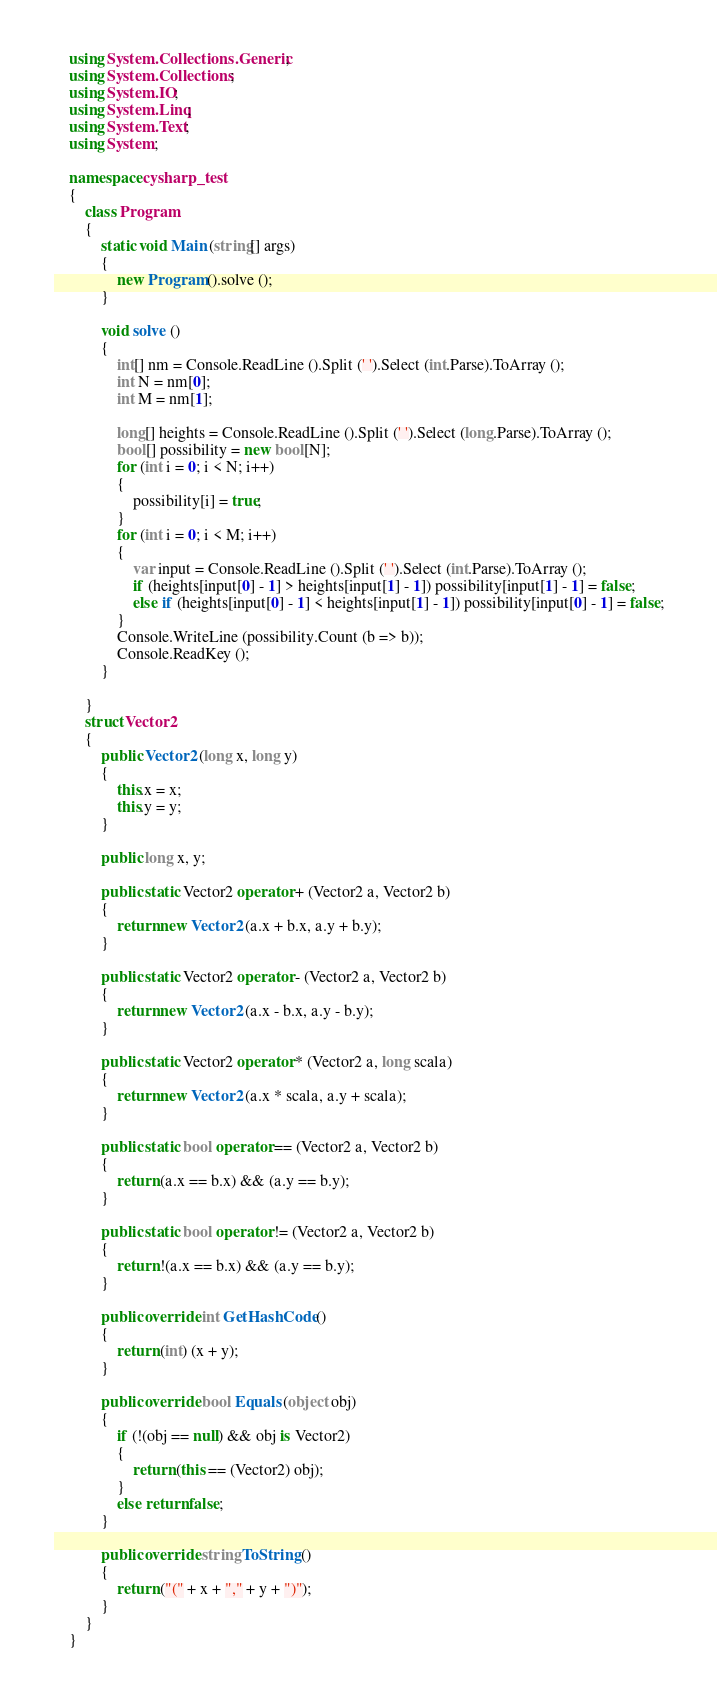Convert code to text. <code><loc_0><loc_0><loc_500><loc_500><_C#_>    using System.Collections.Generic;
    using System.Collections;
    using System.IO;
    using System.Linq;
    using System.Text;
    using System;

    namespace cysharp_test
    {
        class Program
        {
            static void Main (string[] args)
            {
                new Program ().solve ();
            }

            void solve ()
            {
                int[] nm = Console.ReadLine ().Split (' ').Select (int.Parse).ToArray ();
                int N = nm[0];
                int M = nm[1];

                long[] heights = Console.ReadLine ().Split (' ').Select (long.Parse).ToArray ();
                bool[] possibility = new bool[N];
                for (int i = 0; i < N; i++)
                {
                    possibility[i] = true;
                }
                for (int i = 0; i < M; i++)
                {
                    var input = Console.ReadLine ().Split (' ').Select (int.Parse).ToArray ();
                    if (heights[input[0] - 1] > heights[input[1] - 1]) possibility[input[1] - 1] = false;
                    else if (heights[input[0] - 1] < heights[input[1] - 1]) possibility[input[0] - 1] = false;
                }
                Console.WriteLine (possibility.Count (b => b));
                Console.ReadKey ();
            }

        }
        struct Vector2
        {
            public Vector2 (long x, long y)
            {
                this.x = x;
                this.y = y;
            }

            public long x, y;

            public static Vector2 operator + (Vector2 a, Vector2 b)
            {
                return new Vector2 (a.x + b.x, a.y + b.y);
            }

            public static Vector2 operator - (Vector2 a, Vector2 b)
            {
                return new Vector2 (a.x - b.x, a.y - b.y);
            }

            public static Vector2 operator * (Vector2 a, long scala)
            {
                return new Vector2 (a.x * scala, a.y + scala);
            }

            public static bool operator == (Vector2 a, Vector2 b)
            {
                return (a.x == b.x) && (a.y == b.y);
            }

            public static bool operator != (Vector2 a, Vector2 b)
            {
                return !(a.x == b.x) && (a.y == b.y);
            }

            public override int GetHashCode ()
            {
                return (int) (x + y);
            }

            public override bool Equals (object obj)
            {
                if (!(obj == null) && obj is Vector2)
                {
                    return (this == (Vector2) obj);
                }
                else return false;
            }

            public override string ToString ()
            {
                return ("(" + x + "," + y + ")");
            }
        }
    }</code> 